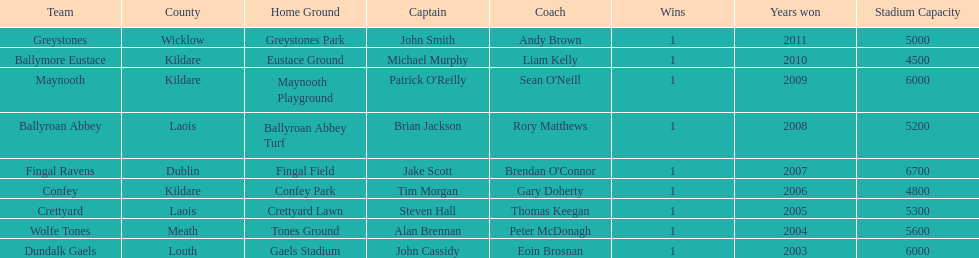How many wins did confey have? 1. 